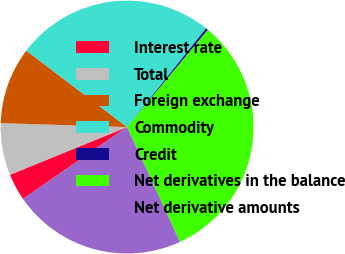Convert chart. <chart><loc_0><loc_0><loc_500><loc_500><pie_chart><fcel>Interest rate<fcel>Total<fcel>Foreign exchange<fcel>Commodity<fcel>Credit<fcel>Net derivatives in the balance<fcel>Net derivative amounts<nl><fcel>3.47%<fcel>6.65%<fcel>9.83%<fcel>25.42%<fcel>0.29%<fcel>32.11%<fcel>22.24%<nl></chart> 